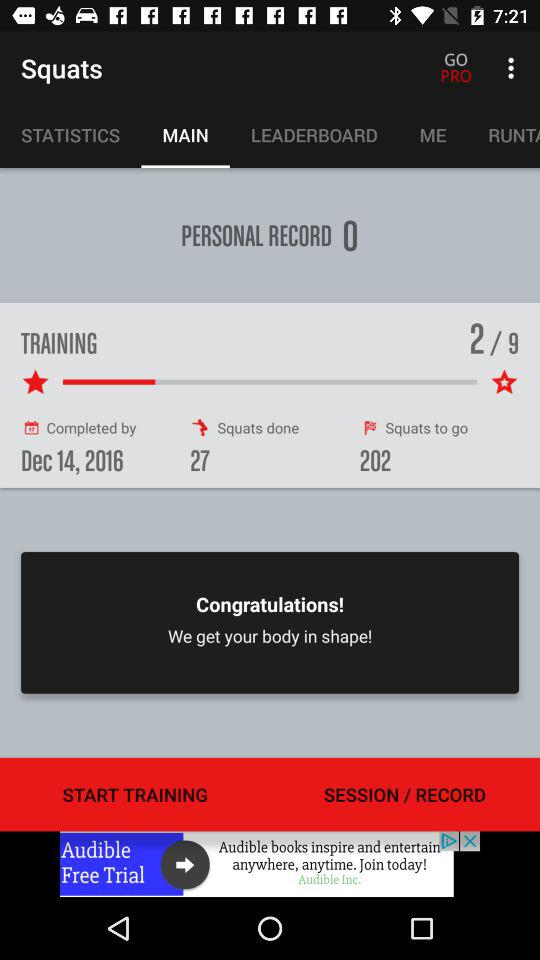How many squats are left to do?
Answer the question using a single word or phrase. 202 